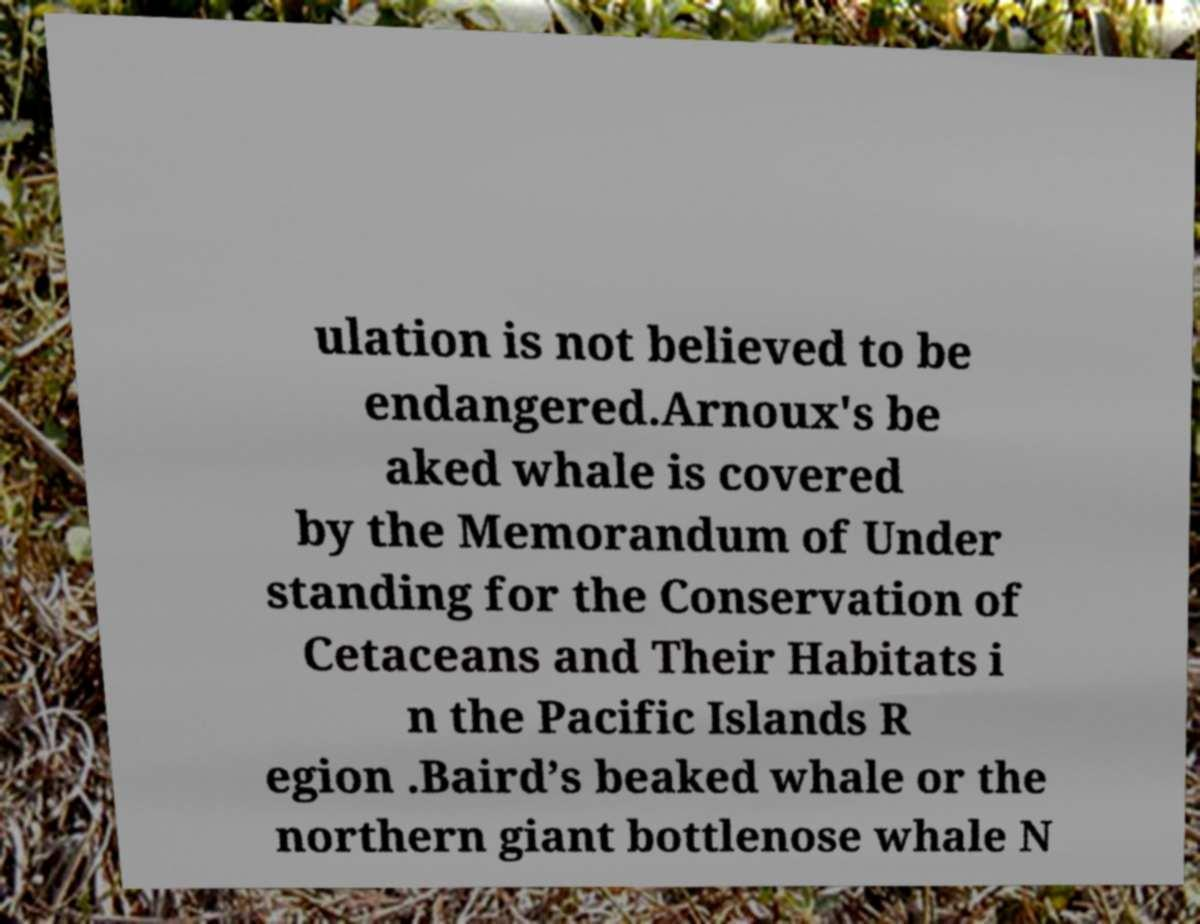There's text embedded in this image that I need extracted. Can you transcribe it verbatim? ulation is not believed to be endangered.Arnoux's be aked whale is covered by the Memorandum of Under standing for the Conservation of Cetaceans and Their Habitats i n the Pacific Islands R egion .Baird’s beaked whale or the northern giant bottlenose whale N 